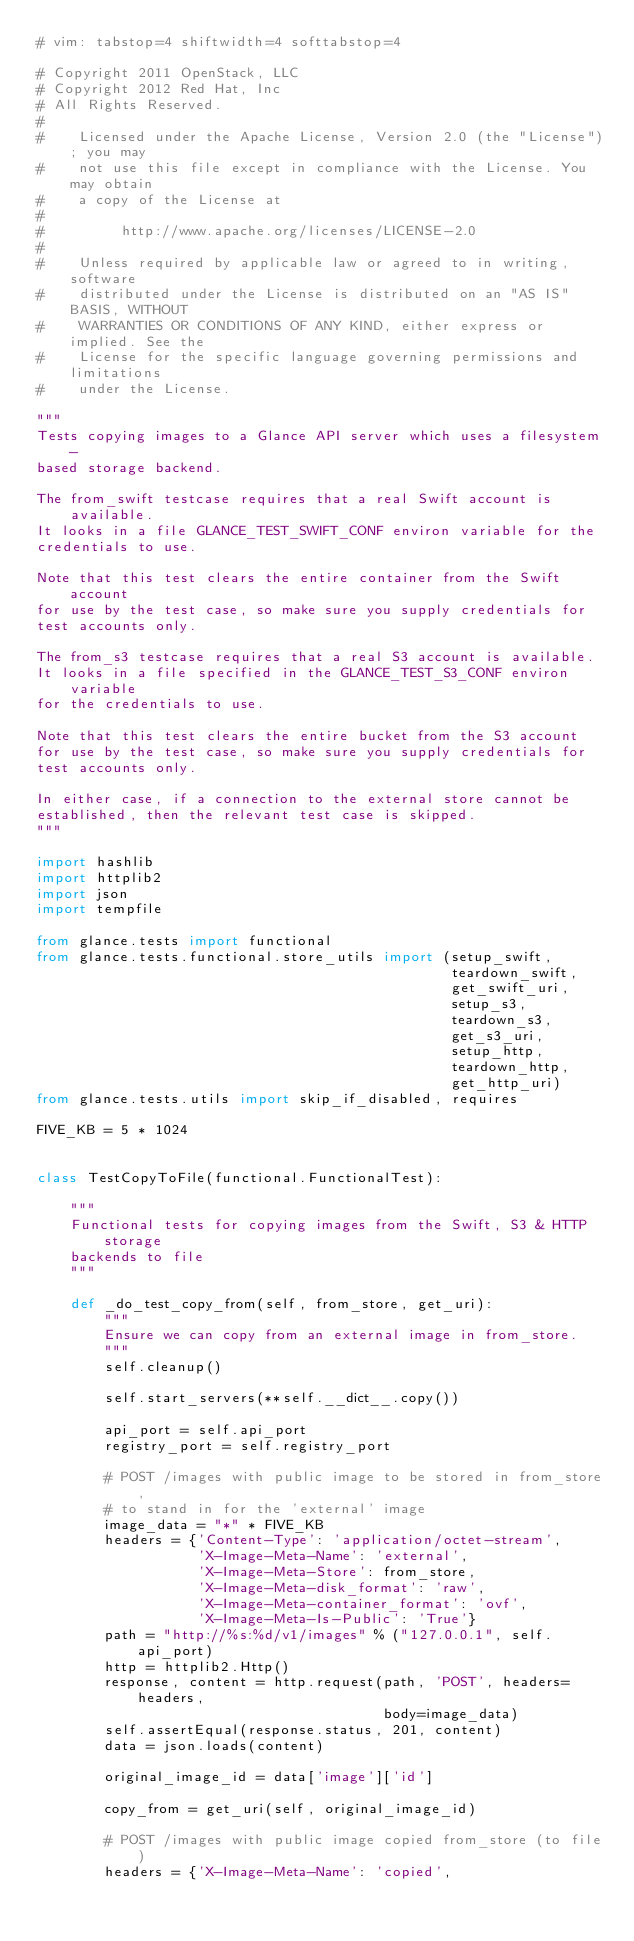<code> <loc_0><loc_0><loc_500><loc_500><_Python_># vim: tabstop=4 shiftwidth=4 softtabstop=4

# Copyright 2011 OpenStack, LLC
# Copyright 2012 Red Hat, Inc
# All Rights Reserved.
#
#    Licensed under the Apache License, Version 2.0 (the "License"); you may
#    not use this file except in compliance with the License. You may obtain
#    a copy of the License at
#
#         http://www.apache.org/licenses/LICENSE-2.0
#
#    Unless required by applicable law or agreed to in writing, software
#    distributed under the License is distributed on an "AS IS" BASIS, WITHOUT
#    WARRANTIES OR CONDITIONS OF ANY KIND, either express or implied. See the
#    License for the specific language governing permissions and limitations
#    under the License.

"""
Tests copying images to a Glance API server which uses a filesystem-
based storage backend.

The from_swift testcase requires that a real Swift account is available.
It looks in a file GLANCE_TEST_SWIFT_CONF environ variable for the
credentials to use.

Note that this test clears the entire container from the Swift account
for use by the test case, so make sure you supply credentials for
test accounts only.

The from_s3 testcase requires that a real S3 account is available.
It looks in a file specified in the GLANCE_TEST_S3_CONF environ variable
for the credentials to use.

Note that this test clears the entire bucket from the S3 account
for use by the test case, so make sure you supply credentials for
test accounts only.

In either case, if a connection to the external store cannot be
established, then the relevant test case is skipped.
"""

import hashlib
import httplib2
import json
import tempfile

from glance.tests import functional
from glance.tests.functional.store_utils import (setup_swift,
                                                 teardown_swift,
                                                 get_swift_uri,
                                                 setup_s3,
                                                 teardown_s3,
                                                 get_s3_uri,
                                                 setup_http,
                                                 teardown_http,
                                                 get_http_uri)
from glance.tests.utils import skip_if_disabled, requires

FIVE_KB = 5 * 1024


class TestCopyToFile(functional.FunctionalTest):

    """
    Functional tests for copying images from the Swift, S3 & HTTP storage
    backends to file
    """

    def _do_test_copy_from(self, from_store, get_uri):
        """
        Ensure we can copy from an external image in from_store.
        """
        self.cleanup()

        self.start_servers(**self.__dict__.copy())

        api_port = self.api_port
        registry_port = self.registry_port

        # POST /images with public image to be stored in from_store,
        # to stand in for the 'external' image
        image_data = "*" * FIVE_KB
        headers = {'Content-Type': 'application/octet-stream',
                   'X-Image-Meta-Name': 'external',
                   'X-Image-Meta-Store': from_store,
                   'X-Image-Meta-disk_format': 'raw',
                   'X-Image-Meta-container_format': 'ovf',
                   'X-Image-Meta-Is-Public': 'True'}
        path = "http://%s:%d/v1/images" % ("127.0.0.1", self.api_port)
        http = httplib2.Http()
        response, content = http.request(path, 'POST', headers=headers,
                                         body=image_data)
        self.assertEqual(response.status, 201, content)
        data = json.loads(content)

        original_image_id = data['image']['id']

        copy_from = get_uri(self, original_image_id)

        # POST /images with public image copied from_store (to file)
        headers = {'X-Image-Meta-Name': 'copied',</code> 